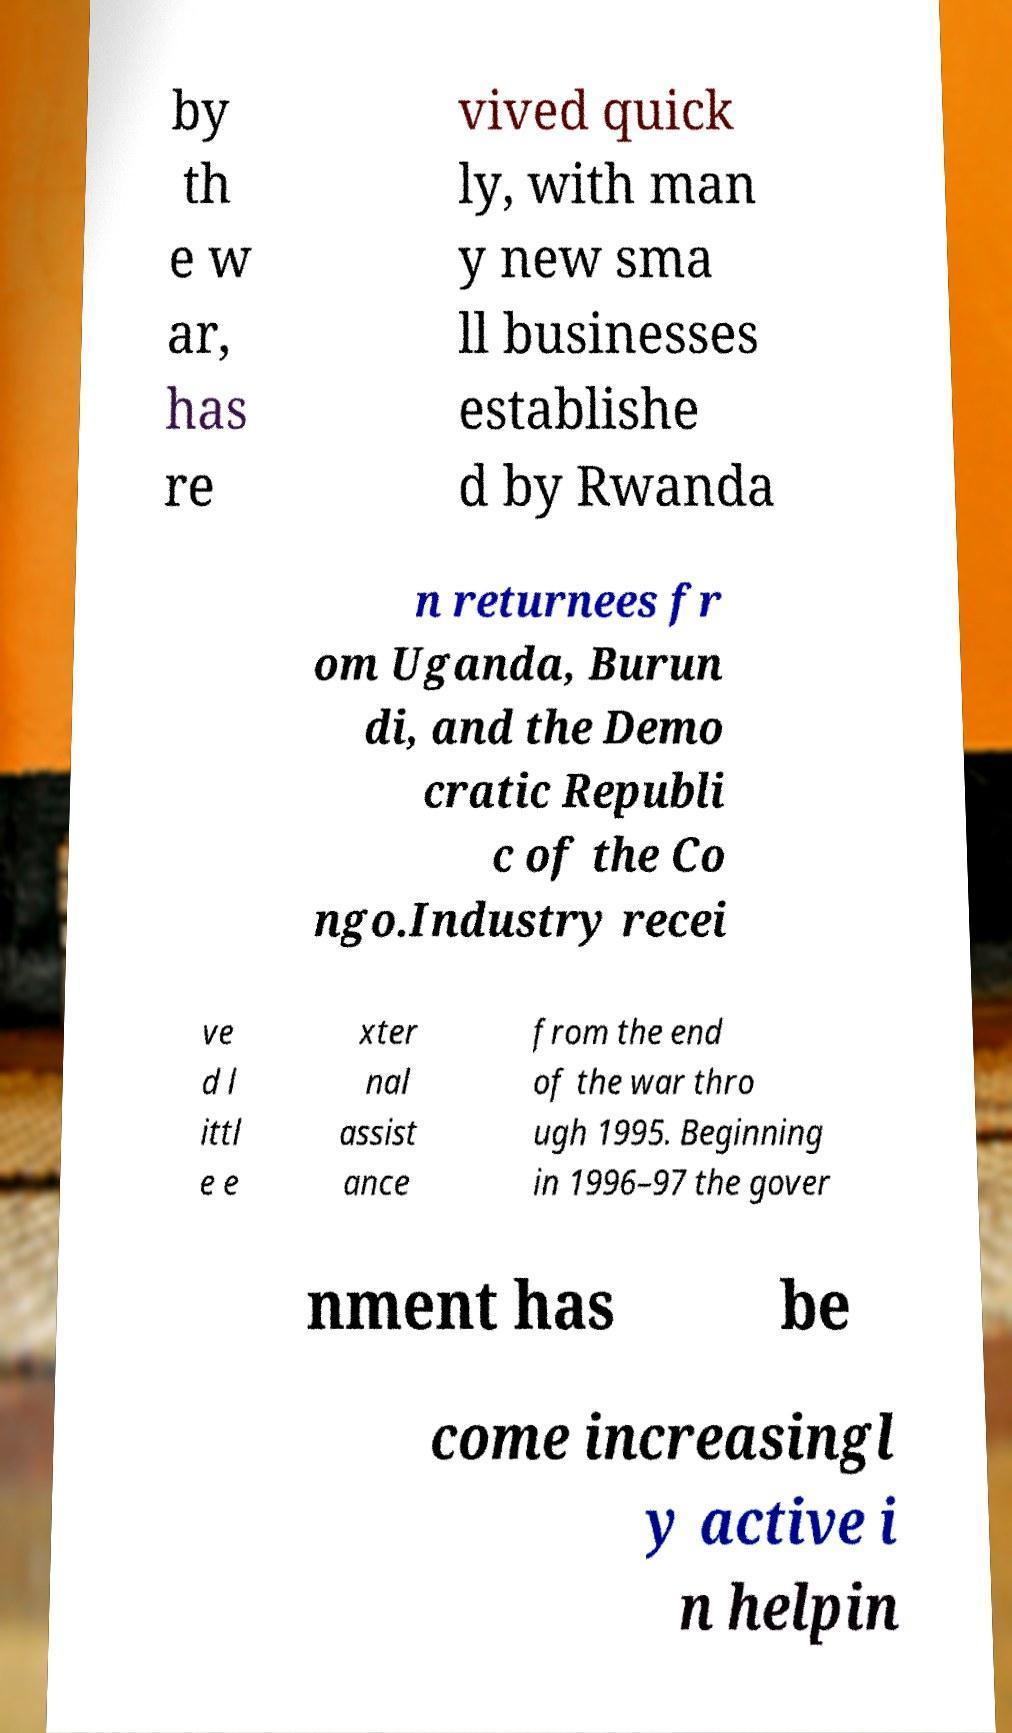What messages or text are displayed in this image? I need them in a readable, typed format. by th e w ar, has re vived quick ly, with man y new sma ll businesses establishe d by Rwanda n returnees fr om Uganda, Burun di, and the Demo cratic Republi c of the Co ngo.Industry recei ve d l ittl e e xter nal assist ance from the end of the war thro ugh 1995. Beginning in 1996–97 the gover nment has be come increasingl y active i n helpin 